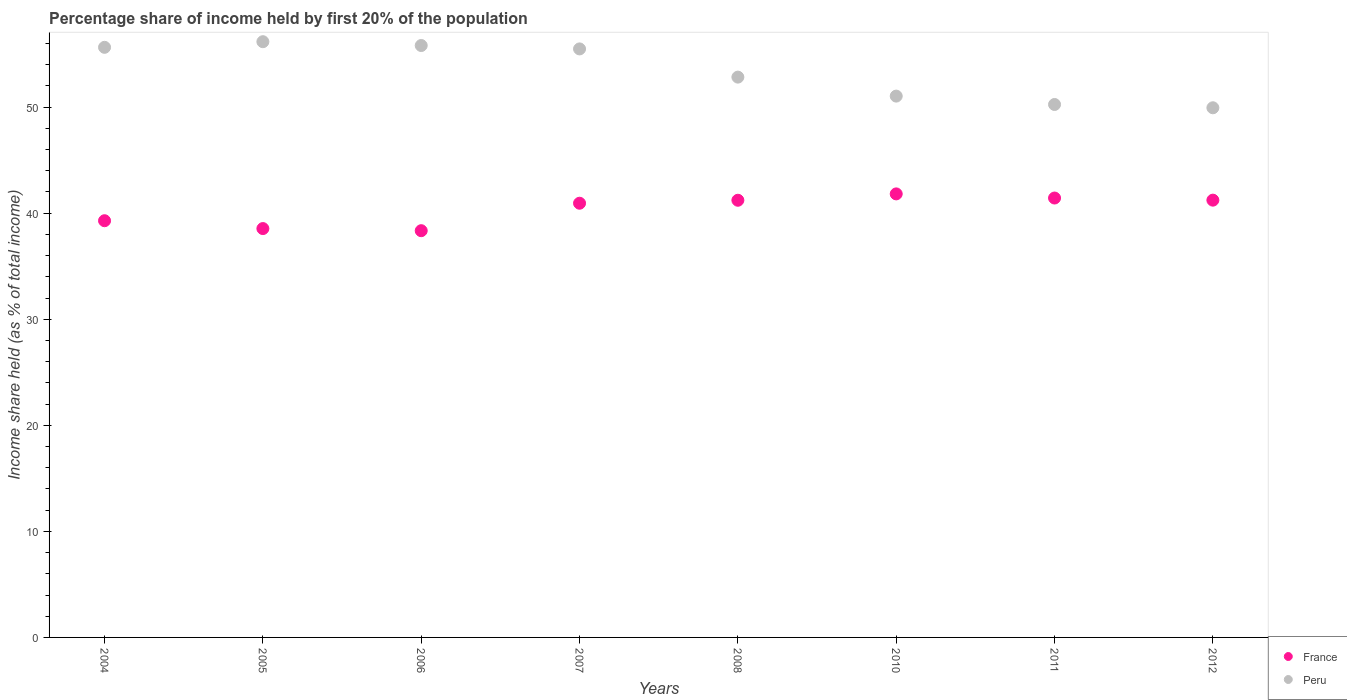Is the number of dotlines equal to the number of legend labels?
Provide a succinct answer. Yes. What is the share of income held by first 20% of the population in France in 2007?
Offer a very short reply. 40.94. Across all years, what is the maximum share of income held by first 20% of the population in France?
Provide a short and direct response. 41.82. Across all years, what is the minimum share of income held by first 20% of the population in Peru?
Offer a very short reply. 49.94. In which year was the share of income held by first 20% of the population in Peru maximum?
Offer a terse response. 2005. What is the total share of income held by first 20% of the population in Peru in the graph?
Provide a short and direct response. 427.17. What is the difference between the share of income held by first 20% of the population in Peru in 2011 and that in 2012?
Give a very brief answer. 0.31. What is the difference between the share of income held by first 20% of the population in France in 2005 and the share of income held by first 20% of the population in Peru in 2010?
Give a very brief answer. -12.49. What is the average share of income held by first 20% of the population in France per year?
Provide a short and direct response. 40.35. In the year 2005, what is the difference between the share of income held by first 20% of the population in France and share of income held by first 20% of the population in Peru?
Give a very brief answer. -17.62. In how many years, is the share of income held by first 20% of the population in France greater than 16 %?
Make the answer very short. 8. What is the ratio of the share of income held by first 20% of the population in France in 2010 to that in 2011?
Your answer should be very brief. 1.01. Is the share of income held by first 20% of the population in Peru in 2004 less than that in 2006?
Offer a very short reply. Yes. Is the difference between the share of income held by first 20% of the population in France in 2004 and 2011 greater than the difference between the share of income held by first 20% of the population in Peru in 2004 and 2011?
Give a very brief answer. No. What is the difference between the highest and the second highest share of income held by first 20% of the population in Peru?
Keep it short and to the point. 0.36. What is the difference between the highest and the lowest share of income held by first 20% of the population in Peru?
Make the answer very short. 6.23. In how many years, is the share of income held by first 20% of the population in France greater than the average share of income held by first 20% of the population in France taken over all years?
Ensure brevity in your answer.  5. Is the share of income held by first 20% of the population in Peru strictly greater than the share of income held by first 20% of the population in France over the years?
Keep it short and to the point. Yes. Are the values on the major ticks of Y-axis written in scientific E-notation?
Provide a short and direct response. No. Does the graph contain any zero values?
Make the answer very short. No. Does the graph contain grids?
Offer a terse response. No. How many legend labels are there?
Your response must be concise. 2. How are the legend labels stacked?
Ensure brevity in your answer.  Vertical. What is the title of the graph?
Your answer should be very brief. Percentage share of income held by first 20% of the population. Does "Monaco" appear as one of the legend labels in the graph?
Make the answer very short. No. What is the label or title of the Y-axis?
Your answer should be compact. Income share held (as % of total income). What is the Income share held (as % of total income) of France in 2004?
Provide a succinct answer. 39.29. What is the Income share held (as % of total income) in Peru in 2004?
Your answer should be very brief. 55.64. What is the Income share held (as % of total income) of France in 2005?
Ensure brevity in your answer.  38.55. What is the Income share held (as % of total income) of Peru in 2005?
Give a very brief answer. 56.17. What is the Income share held (as % of total income) of France in 2006?
Ensure brevity in your answer.  38.35. What is the Income share held (as % of total income) of Peru in 2006?
Provide a succinct answer. 55.81. What is the Income share held (as % of total income) of France in 2007?
Offer a very short reply. 40.94. What is the Income share held (as % of total income) in Peru in 2007?
Offer a terse response. 55.49. What is the Income share held (as % of total income) in France in 2008?
Give a very brief answer. 41.22. What is the Income share held (as % of total income) in Peru in 2008?
Make the answer very short. 52.83. What is the Income share held (as % of total income) in France in 2010?
Provide a short and direct response. 41.82. What is the Income share held (as % of total income) of Peru in 2010?
Ensure brevity in your answer.  51.04. What is the Income share held (as % of total income) of France in 2011?
Keep it short and to the point. 41.43. What is the Income share held (as % of total income) in Peru in 2011?
Your answer should be compact. 50.25. What is the Income share held (as % of total income) in France in 2012?
Offer a terse response. 41.23. What is the Income share held (as % of total income) in Peru in 2012?
Offer a very short reply. 49.94. Across all years, what is the maximum Income share held (as % of total income) of France?
Your response must be concise. 41.82. Across all years, what is the maximum Income share held (as % of total income) in Peru?
Give a very brief answer. 56.17. Across all years, what is the minimum Income share held (as % of total income) of France?
Ensure brevity in your answer.  38.35. Across all years, what is the minimum Income share held (as % of total income) of Peru?
Give a very brief answer. 49.94. What is the total Income share held (as % of total income) of France in the graph?
Make the answer very short. 322.83. What is the total Income share held (as % of total income) of Peru in the graph?
Ensure brevity in your answer.  427.17. What is the difference between the Income share held (as % of total income) of France in 2004 and that in 2005?
Your response must be concise. 0.74. What is the difference between the Income share held (as % of total income) in Peru in 2004 and that in 2005?
Offer a terse response. -0.53. What is the difference between the Income share held (as % of total income) of Peru in 2004 and that in 2006?
Offer a very short reply. -0.17. What is the difference between the Income share held (as % of total income) in France in 2004 and that in 2007?
Offer a very short reply. -1.65. What is the difference between the Income share held (as % of total income) of Peru in 2004 and that in 2007?
Offer a very short reply. 0.15. What is the difference between the Income share held (as % of total income) in France in 2004 and that in 2008?
Keep it short and to the point. -1.93. What is the difference between the Income share held (as % of total income) of Peru in 2004 and that in 2008?
Make the answer very short. 2.81. What is the difference between the Income share held (as % of total income) of France in 2004 and that in 2010?
Offer a terse response. -2.53. What is the difference between the Income share held (as % of total income) of Peru in 2004 and that in 2010?
Offer a terse response. 4.6. What is the difference between the Income share held (as % of total income) in France in 2004 and that in 2011?
Your response must be concise. -2.14. What is the difference between the Income share held (as % of total income) in Peru in 2004 and that in 2011?
Ensure brevity in your answer.  5.39. What is the difference between the Income share held (as % of total income) in France in 2004 and that in 2012?
Your answer should be very brief. -1.94. What is the difference between the Income share held (as % of total income) in Peru in 2005 and that in 2006?
Make the answer very short. 0.36. What is the difference between the Income share held (as % of total income) of France in 2005 and that in 2007?
Make the answer very short. -2.39. What is the difference between the Income share held (as % of total income) of Peru in 2005 and that in 2007?
Your answer should be very brief. 0.68. What is the difference between the Income share held (as % of total income) of France in 2005 and that in 2008?
Provide a short and direct response. -2.67. What is the difference between the Income share held (as % of total income) in Peru in 2005 and that in 2008?
Give a very brief answer. 3.34. What is the difference between the Income share held (as % of total income) in France in 2005 and that in 2010?
Provide a short and direct response. -3.27. What is the difference between the Income share held (as % of total income) of Peru in 2005 and that in 2010?
Give a very brief answer. 5.13. What is the difference between the Income share held (as % of total income) of France in 2005 and that in 2011?
Your answer should be compact. -2.88. What is the difference between the Income share held (as % of total income) in Peru in 2005 and that in 2011?
Keep it short and to the point. 5.92. What is the difference between the Income share held (as % of total income) of France in 2005 and that in 2012?
Your answer should be very brief. -2.68. What is the difference between the Income share held (as % of total income) of Peru in 2005 and that in 2012?
Keep it short and to the point. 6.23. What is the difference between the Income share held (as % of total income) in France in 2006 and that in 2007?
Provide a succinct answer. -2.59. What is the difference between the Income share held (as % of total income) of Peru in 2006 and that in 2007?
Provide a succinct answer. 0.32. What is the difference between the Income share held (as % of total income) in France in 2006 and that in 2008?
Your answer should be compact. -2.87. What is the difference between the Income share held (as % of total income) of Peru in 2006 and that in 2008?
Ensure brevity in your answer.  2.98. What is the difference between the Income share held (as % of total income) of France in 2006 and that in 2010?
Make the answer very short. -3.47. What is the difference between the Income share held (as % of total income) in Peru in 2006 and that in 2010?
Ensure brevity in your answer.  4.77. What is the difference between the Income share held (as % of total income) of France in 2006 and that in 2011?
Keep it short and to the point. -3.08. What is the difference between the Income share held (as % of total income) in Peru in 2006 and that in 2011?
Provide a succinct answer. 5.56. What is the difference between the Income share held (as % of total income) of France in 2006 and that in 2012?
Your response must be concise. -2.88. What is the difference between the Income share held (as % of total income) in Peru in 2006 and that in 2012?
Your response must be concise. 5.87. What is the difference between the Income share held (as % of total income) in France in 2007 and that in 2008?
Provide a short and direct response. -0.28. What is the difference between the Income share held (as % of total income) of Peru in 2007 and that in 2008?
Provide a short and direct response. 2.66. What is the difference between the Income share held (as % of total income) in France in 2007 and that in 2010?
Offer a terse response. -0.88. What is the difference between the Income share held (as % of total income) in Peru in 2007 and that in 2010?
Make the answer very short. 4.45. What is the difference between the Income share held (as % of total income) of France in 2007 and that in 2011?
Your answer should be very brief. -0.49. What is the difference between the Income share held (as % of total income) in Peru in 2007 and that in 2011?
Give a very brief answer. 5.24. What is the difference between the Income share held (as % of total income) of France in 2007 and that in 2012?
Offer a terse response. -0.29. What is the difference between the Income share held (as % of total income) in Peru in 2007 and that in 2012?
Offer a very short reply. 5.55. What is the difference between the Income share held (as % of total income) in France in 2008 and that in 2010?
Provide a short and direct response. -0.6. What is the difference between the Income share held (as % of total income) in Peru in 2008 and that in 2010?
Offer a very short reply. 1.79. What is the difference between the Income share held (as % of total income) of France in 2008 and that in 2011?
Make the answer very short. -0.21. What is the difference between the Income share held (as % of total income) in Peru in 2008 and that in 2011?
Provide a short and direct response. 2.58. What is the difference between the Income share held (as % of total income) in France in 2008 and that in 2012?
Keep it short and to the point. -0.01. What is the difference between the Income share held (as % of total income) in Peru in 2008 and that in 2012?
Ensure brevity in your answer.  2.89. What is the difference between the Income share held (as % of total income) in France in 2010 and that in 2011?
Offer a terse response. 0.39. What is the difference between the Income share held (as % of total income) in Peru in 2010 and that in 2011?
Your answer should be very brief. 0.79. What is the difference between the Income share held (as % of total income) in France in 2010 and that in 2012?
Provide a short and direct response. 0.59. What is the difference between the Income share held (as % of total income) of Peru in 2010 and that in 2012?
Make the answer very short. 1.1. What is the difference between the Income share held (as % of total income) in France in 2011 and that in 2012?
Your answer should be compact. 0.2. What is the difference between the Income share held (as % of total income) of Peru in 2011 and that in 2012?
Your answer should be very brief. 0.31. What is the difference between the Income share held (as % of total income) of France in 2004 and the Income share held (as % of total income) of Peru in 2005?
Offer a very short reply. -16.88. What is the difference between the Income share held (as % of total income) in France in 2004 and the Income share held (as % of total income) in Peru in 2006?
Give a very brief answer. -16.52. What is the difference between the Income share held (as % of total income) in France in 2004 and the Income share held (as % of total income) in Peru in 2007?
Offer a very short reply. -16.2. What is the difference between the Income share held (as % of total income) of France in 2004 and the Income share held (as % of total income) of Peru in 2008?
Offer a very short reply. -13.54. What is the difference between the Income share held (as % of total income) in France in 2004 and the Income share held (as % of total income) in Peru in 2010?
Offer a terse response. -11.75. What is the difference between the Income share held (as % of total income) of France in 2004 and the Income share held (as % of total income) of Peru in 2011?
Your response must be concise. -10.96. What is the difference between the Income share held (as % of total income) of France in 2004 and the Income share held (as % of total income) of Peru in 2012?
Your response must be concise. -10.65. What is the difference between the Income share held (as % of total income) of France in 2005 and the Income share held (as % of total income) of Peru in 2006?
Keep it short and to the point. -17.26. What is the difference between the Income share held (as % of total income) of France in 2005 and the Income share held (as % of total income) of Peru in 2007?
Your answer should be very brief. -16.94. What is the difference between the Income share held (as % of total income) of France in 2005 and the Income share held (as % of total income) of Peru in 2008?
Make the answer very short. -14.28. What is the difference between the Income share held (as % of total income) in France in 2005 and the Income share held (as % of total income) in Peru in 2010?
Provide a short and direct response. -12.49. What is the difference between the Income share held (as % of total income) of France in 2005 and the Income share held (as % of total income) of Peru in 2011?
Offer a very short reply. -11.7. What is the difference between the Income share held (as % of total income) of France in 2005 and the Income share held (as % of total income) of Peru in 2012?
Keep it short and to the point. -11.39. What is the difference between the Income share held (as % of total income) in France in 2006 and the Income share held (as % of total income) in Peru in 2007?
Your answer should be very brief. -17.14. What is the difference between the Income share held (as % of total income) of France in 2006 and the Income share held (as % of total income) of Peru in 2008?
Provide a succinct answer. -14.48. What is the difference between the Income share held (as % of total income) in France in 2006 and the Income share held (as % of total income) in Peru in 2010?
Make the answer very short. -12.69. What is the difference between the Income share held (as % of total income) in France in 2006 and the Income share held (as % of total income) in Peru in 2011?
Your answer should be compact. -11.9. What is the difference between the Income share held (as % of total income) of France in 2006 and the Income share held (as % of total income) of Peru in 2012?
Keep it short and to the point. -11.59. What is the difference between the Income share held (as % of total income) of France in 2007 and the Income share held (as % of total income) of Peru in 2008?
Your answer should be compact. -11.89. What is the difference between the Income share held (as % of total income) in France in 2007 and the Income share held (as % of total income) in Peru in 2011?
Make the answer very short. -9.31. What is the difference between the Income share held (as % of total income) in France in 2007 and the Income share held (as % of total income) in Peru in 2012?
Provide a short and direct response. -9. What is the difference between the Income share held (as % of total income) in France in 2008 and the Income share held (as % of total income) in Peru in 2010?
Provide a short and direct response. -9.82. What is the difference between the Income share held (as % of total income) of France in 2008 and the Income share held (as % of total income) of Peru in 2011?
Provide a short and direct response. -9.03. What is the difference between the Income share held (as % of total income) of France in 2008 and the Income share held (as % of total income) of Peru in 2012?
Give a very brief answer. -8.72. What is the difference between the Income share held (as % of total income) in France in 2010 and the Income share held (as % of total income) in Peru in 2011?
Give a very brief answer. -8.43. What is the difference between the Income share held (as % of total income) in France in 2010 and the Income share held (as % of total income) in Peru in 2012?
Your answer should be very brief. -8.12. What is the difference between the Income share held (as % of total income) in France in 2011 and the Income share held (as % of total income) in Peru in 2012?
Offer a very short reply. -8.51. What is the average Income share held (as % of total income) in France per year?
Your response must be concise. 40.35. What is the average Income share held (as % of total income) in Peru per year?
Your response must be concise. 53.4. In the year 2004, what is the difference between the Income share held (as % of total income) of France and Income share held (as % of total income) of Peru?
Ensure brevity in your answer.  -16.35. In the year 2005, what is the difference between the Income share held (as % of total income) of France and Income share held (as % of total income) of Peru?
Keep it short and to the point. -17.62. In the year 2006, what is the difference between the Income share held (as % of total income) in France and Income share held (as % of total income) in Peru?
Your answer should be compact. -17.46. In the year 2007, what is the difference between the Income share held (as % of total income) in France and Income share held (as % of total income) in Peru?
Offer a very short reply. -14.55. In the year 2008, what is the difference between the Income share held (as % of total income) in France and Income share held (as % of total income) in Peru?
Keep it short and to the point. -11.61. In the year 2010, what is the difference between the Income share held (as % of total income) in France and Income share held (as % of total income) in Peru?
Your response must be concise. -9.22. In the year 2011, what is the difference between the Income share held (as % of total income) in France and Income share held (as % of total income) in Peru?
Your answer should be very brief. -8.82. In the year 2012, what is the difference between the Income share held (as % of total income) of France and Income share held (as % of total income) of Peru?
Provide a succinct answer. -8.71. What is the ratio of the Income share held (as % of total income) of France in 2004 to that in 2005?
Ensure brevity in your answer.  1.02. What is the ratio of the Income share held (as % of total income) of Peru in 2004 to that in 2005?
Your answer should be compact. 0.99. What is the ratio of the Income share held (as % of total income) of France in 2004 to that in 2006?
Keep it short and to the point. 1.02. What is the ratio of the Income share held (as % of total income) of Peru in 2004 to that in 2006?
Ensure brevity in your answer.  1. What is the ratio of the Income share held (as % of total income) of France in 2004 to that in 2007?
Your answer should be compact. 0.96. What is the ratio of the Income share held (as % of total income) in France in 2004 to that in 2008?
Provide a succinct answer. 0.95. What is the ratio of the Income share held (as % of total income) in Peru in 2004 to that in 2008?
Your response must be concise. 1.05. What is the ratio of the Income share held (as % of total income) of France in 2004 to that in 2010?
Your answer should be very brief. 0.94. What is the ratio of the Income share held (as % of total income) in Peru in 2004 to that in 2010?
Give a very brief answer. 1.09. What is the ratio of the Income share held (as % of total income) in France in 2004 to that in 2011?
Provide a short and direct response. 0.95. What is the ratio of the Income share held (as % of total income) of Peru in 2004 to that in 2011?
Keep it short and to the point. 1.11. What is the ratio of the Income share held (as % of total income) in France in 2004 to that in 2012?
Ensure brevity in your answer.  0.95. What is the ratio of the Income share held (as % of total income) in Peru in 2004 to that in 2012?
Give a very brief answer. 1.11. What is the ratio of the Income share held (as % of total income) in France in 2005 to that in 2006?
Offer a very short reply. 1.01. What is the ratio of the Income share held (as % of total income) of France in 2005 to that in 2007?
Keep it short and to the point. 0.94. What is the ratio of the Income share held (as % of total income) of Peru in 2005 to that in 2007?
Make the answer very short. 1.01. What is the ratio of the Income share held (as % of total income) in France in 2005 to that in 2008?
Keep it short and to the point. 0.94. What is the ratio of the Income share held (as % of total income) of Peru in 2005 to that in 2008?
Offer a very short reply. 1.06. What is the ratio of the Income share held (as % of total income) of France in 2005 to that in 2010?
Keep it short and to the point. 0.92. What is the ratio of the Income share held (as % of total income) in Peru in 2005 to that in 2010?
Make the answer very short. 1.1. What is the ratio of the Income share held (as % of total income) in France in 2005 to that in 2011?
Make the answer very short. 0.93. What is the ratio of the Income share held (as % of total income) of Peru in 2005 to that in 2011?
Make the answer very short. 1.12. What is the ratio of the Income share held (as % of total income) of France in 2005 to that in 2012?
Your response must be concise. 0.94. What is the ratio of the Income share held (as % of total income) of Peru in 2005 to that in 2012?
Your answer should be compact. 1.12. What is the ratio of the Income share held (as % of total income) of France in 2006 to that in 2007?
Make the answer very short. 0.94. What is the ratio of the Income share held (as % of total income) in Peru in 2006 to that in 2007?
Keep it short and to the point. 1.01. What is the ratio of the Income share held (as % of total income) in France in 2006 to that in 2008?
Your answer should be very brief. 0.93. What is the ratio of the Income share held (as % of total income) of Peru in 2006 to that in 2008?
Provide a short and direct response. 1.06. What is the ratio of the Income share held (as % of total income) of France in 2006 to that in 2010?
Keep it short and to the point. 0.92. What is the ratio of the Income share held (as % of total income) in Peru in 2006 to that in 2010?
Make the answer very short. 1.09. What is the ratio of the Income share held (as % of total income) in France in 2006 to that in 2011?
Give a very brief answer. 0.93. What is the ratio of the Income share held (as % of total income) in Peru in 2006 to that in 2011?
Offer a terse response. 1.11. What is the ratio of the Income share held (as % of total income) of France in 2006 to that in 2012?
Keep it short and to the point. 0.93. What is the ratio of the Income share held (as % of total income) of Peru in 2006 to that in 2012?
Your answer should be compact. 1.12. What is the ratio of the Income share held (as % of total income) of Peru in 2007 to that in 2008?
Make the answer very short. 1.05. What is the ratio of the Income share held (as % of total income) in France in 2007 to that in 2010?
Offer a terse response. 0.98. What is the ratio of the Income share held (as % of total income) in Peru in 2007 to that in 2010?
Provide a short and direct response. 1.09. What is the ratio of the Income share held (as % of total income) in France in 2007 to that in 2011?
Make the answer very short. 0.99. What is the ratio of the Income share held (as % of total income) of Peru in 2007 to that in 2011?
Make the answer very short. 1.1. What is the ratio of the Income share held (as % of total income) of France in 2007 to that in 2012?
Give a very brief answer. 0.99. What is the ratio of the Income share held (as % of total income) of France in 2008 to that in 2010?
Make the answer very short. 0.99. What is the ratio of the Income share held (as % of total income) in Peru in 2008 to that in 2010?
Offer a terse response. 1.04. What is the ratio of the Income share held (as % of total income) of Peru in 2008 to that in 2011?
Your answer should be compact. 1.05. What is the ratio of the Income share held (as % of total income) in Peru in 2008 to that in 2012?
Offer a terse response. 1.06. What is the ratio of the Income share held (as % of total income) in France in 2010 to that in 2011?
Your answer should be compact. 1.01. What is the ratio of the Income share held (as % of total income) of Peru in 2010 to that in 2011?
Keep it short and to the point. 1.02. What is the ratio of the Income share held (as % of total income) of France in 2010 to that in 2012?
Offer a terse response. 1.01. What is the ratio of the Income share held (as % of total income) in Peru in 2010 to that in 2012?
Provide a short and direct response. 1.02. What is the difference between the highest and the second highest Income share held (as % of total income) of France?
Keep it short and to the point. 0.39. What is the difference between the highest and the second highest Income share held (as % of total income) of Peru?
Provide a short and direct response. 0.36. What is the difference between the highest and the lowest Income share held (as % of total income) of France?
Ensure brevity in your answer.  3.47. What is the difference between the highest and the lowest Income share held (as % of total income) in Peru?
Keep it short and to the point. 6.23. 